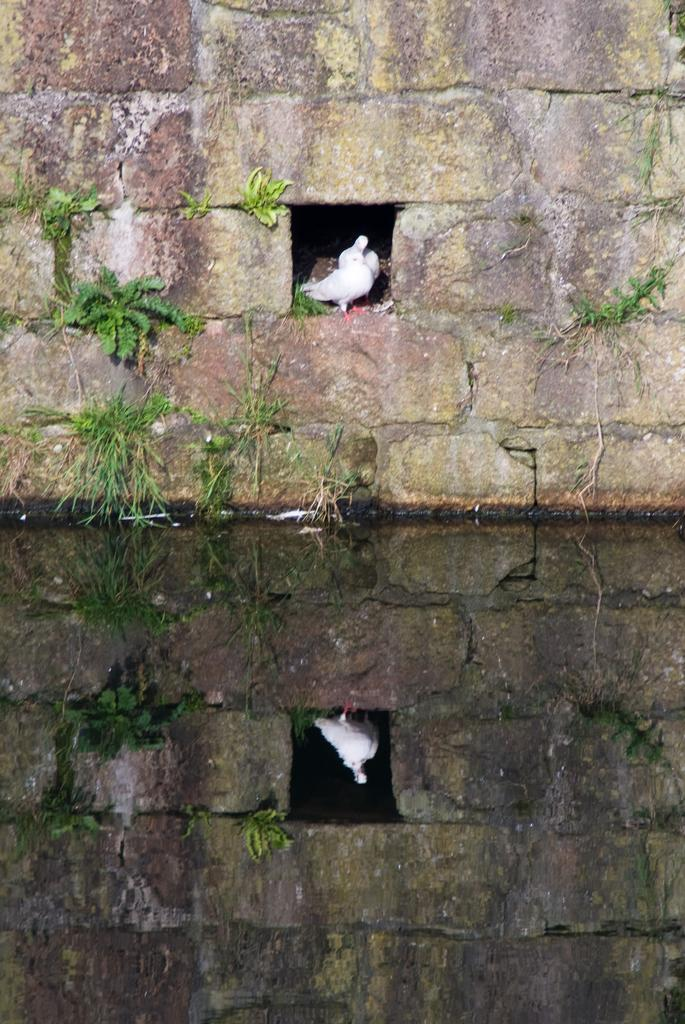What is present at the bottom of the image? There is water at the bottom of the image. What can be seen in the background of the image? There is a wall in the background of the image. What is on the wall in the image? There are pigeons on the wall. What type of wood is being used to build the cattle pen in the image? There is no cattle pen or wood present in the image; it features water at the bottom and a wall with pigeons. 